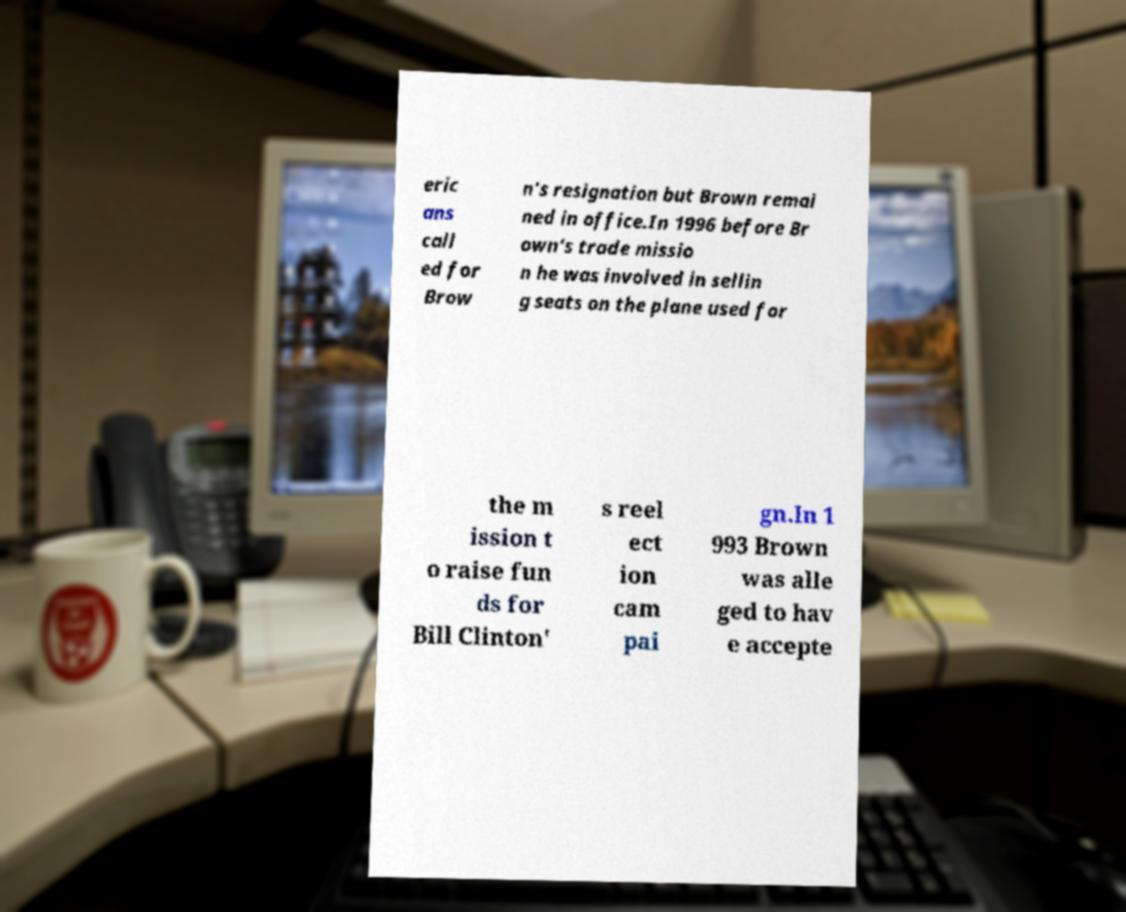Could you extract and type out the text from this image? eric ans call ed for Brow n's resignation but Brown remai ned in office.In 1996 before Br own’s trade missio n he was involved in sellin g seats on the plane used for the m ission t o raise fun ds for Bill Clinton' s reel ect ion cam pai gn.In 1 993 Brown was alle ged to hav e accepte 